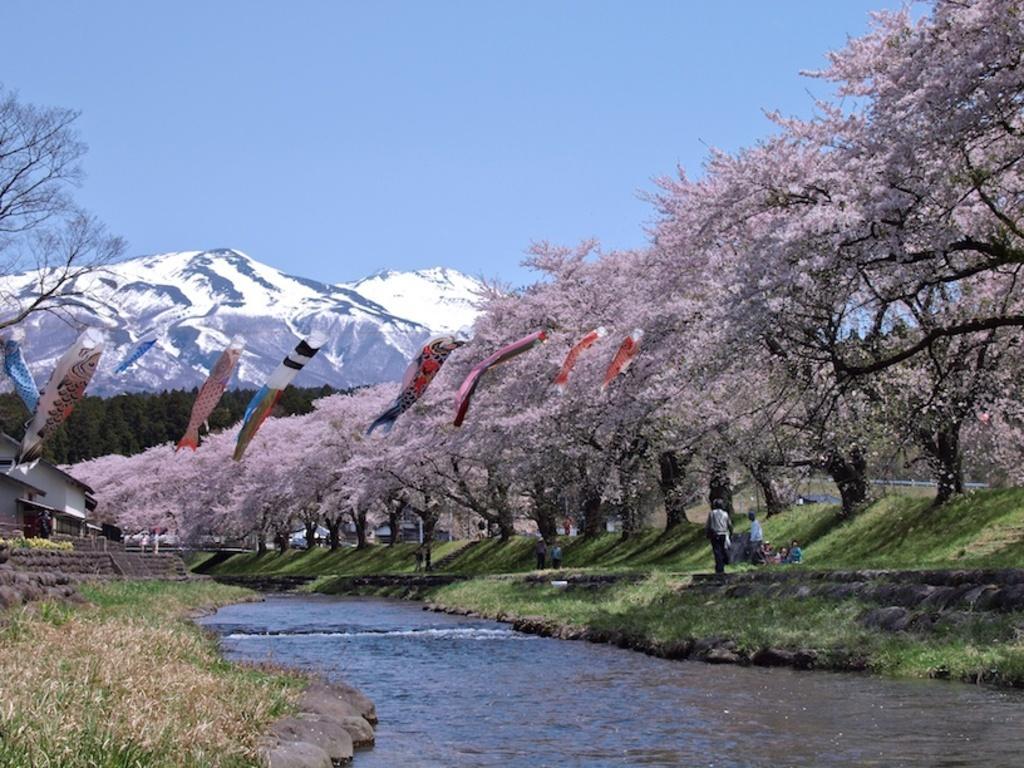Please provide a concise description of this image. In this image at the bottom there is a river, and on the right side and left side there is some grass trees and some persons. On the left side there are some houses and in the center there are some clothes which are flying, and in the background there are some mountains. On the top of the image there is sky. 